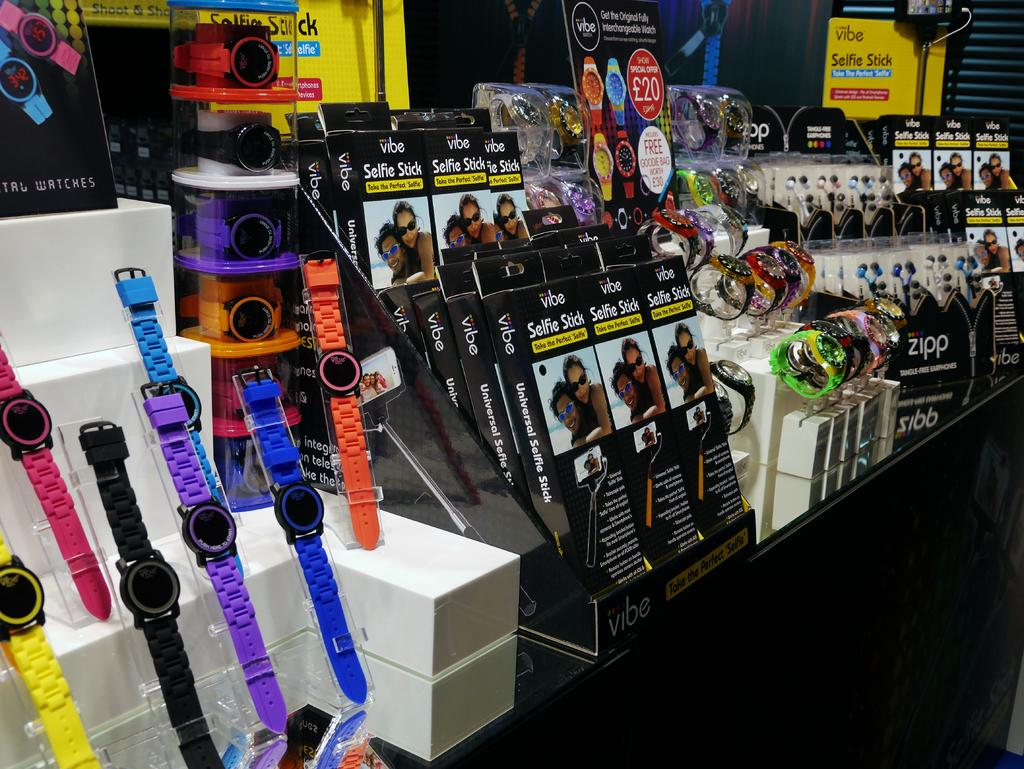What type of items can be seen in the image? There are watches and boxes in the image. Can you describe the unspecified objects in the image? Unfortunately, the provided facts do not specify the nature of the unspecified objects in the image. How many watches are visible in the image? The number of watches is not specified in the provided facts. What type of camera can be seen in the image? There is no camera present in the image; it only features watches and boxes. What kind of structure is visible in the image? There is no structure present in the image; it only features watches and boxes. 